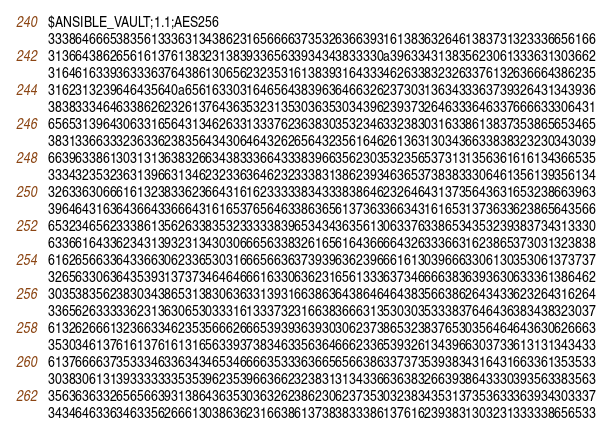<code> <loc_0><loc_0><loc_500><loc_500><_YAML_>$ANSIBLE_VAULT;1.1;AES256
33386466653835613336313438623165666637353263663931613836326461383731323336656166
3136643862656161376138323138393365633934343833330a396334313835623061333631303662
31646163393633363764386130656232353161383931643334626338323263376132636664386235
3162313239646435640a656163303164656438396364663262373031363433363739326431343936
38383334646338626232613764363532313530363530343962393732646333646337666633306431
65653139643063316564313462633133376236383035323463323830316338613837353865653465
38313366333236336238356434306464326265643235616462613631303436633838323230343039
66396338613031313638326634383336643338396635623035323565373131356361616134366535
33343235323631396631346232336364623233383138623934636537383833306461356139356134
32633630666161323833623664316162333338343338386462326464313735643631653238663963
39646431636436643366643161653765646338636561373633663431616531373633623865643566
65323465623338613562633835323333383965343436356130633763386534353239383734313330
63366164336234313932313430306665633832616561643666643263336631623865373031323838
61626566336433663062336530316665663637393963623966616130396663306130353061373737
32656330636435393137373464646661633063623165613336373466663836393630633361386462
30353835623830343865313830636331393166386364386464643835663862643433623264316264
33656263333362313630653033316133373231663836663135303035333837646436383438323037
61326266613236633462353566626665393936393030623738653238376530356464643630626663
35303461376161376161316563393738346335636466623365393261343966303733613131343433
61376666373533346336343465346666353336366565663863373735393834316431663361353533
30383061313933333335353962353966366232383131343366363832663938643330393563383563
35636363326565663931386436353036326238623062373530323834353137353633363934303337
34346463363463356266613038636231663861373838333861376162393831303231333338656533</code> 